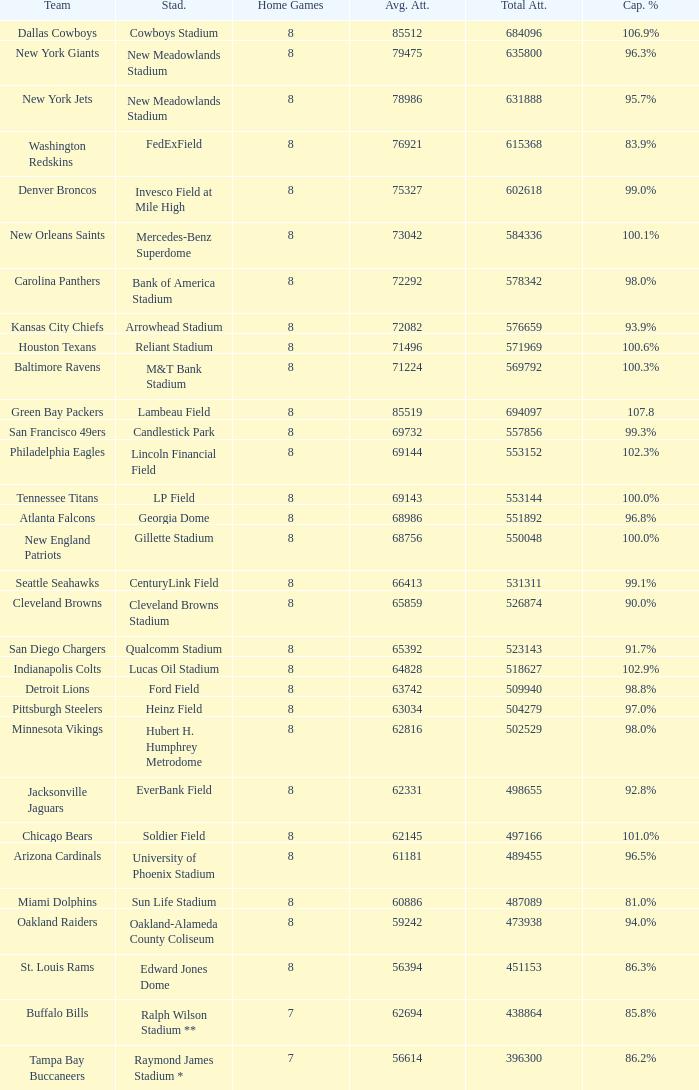What is the number listed in home games when the team is Seattle Seahawks? 8.0. 